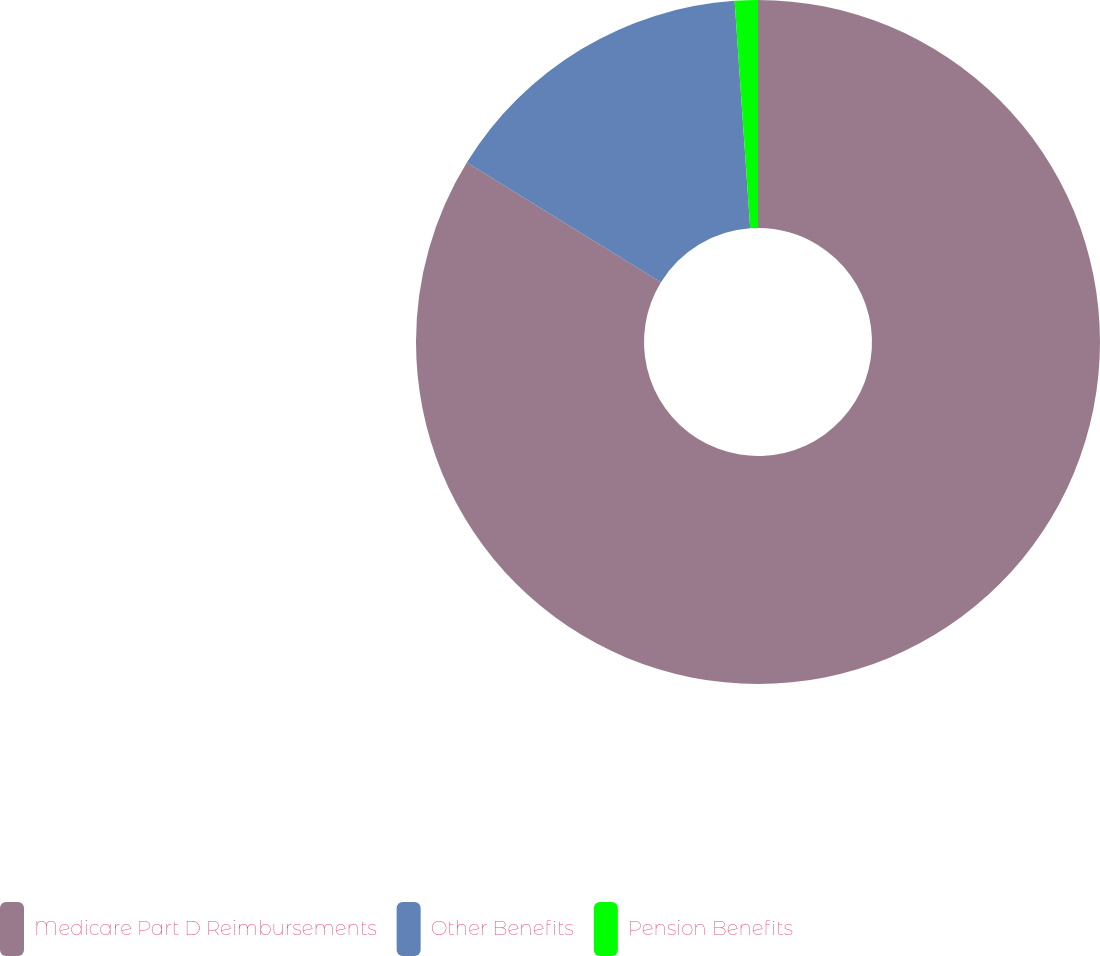<chart> <loc_0><loc_0><loc_500><loc_500><pie_chart><fcel>Medicare Part D Reimbursements<fcel>Other Benefits<fcel>Pension Benefits<nl><fcel>83.79%<fcel>15.12%<fcel>1.09%<nl></chart> 